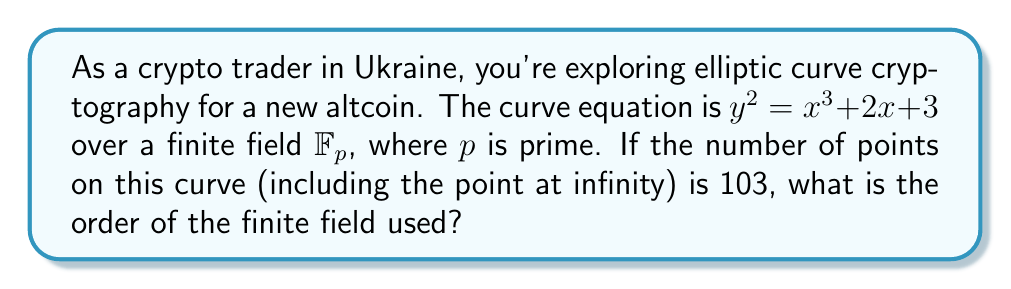Teach me how to tackle this problem. To solve this problem, we'll use Hasse's Theorem, which relates the number of points on an elliptic curve to the order of the finite field.

1) Let $N$ be the number of points on the curve (including the point at infinity). We're given that $N = 103$.

2) Hasse's Theorem states that:

   $$|N - (p + 1)| \leq 2\sqrt{p}$$

   where $p$ is the order of the finite field.

3) We can rewrite this as:

   $$p + 1 - 2\sqrt{p} \leq N \leq p + 1 + 2\sqrt{p}$$

4) Substituting $N = 103$:

   $$p + 1 - 2\sqrt{p} \leq 103 \leq p + 1 + 2\sqrt{p}$$

5) Simplifying the left inequality:

   $$p - 2\sqrt{p} - 102 \leq 0$$

6) And the right inequality:

   $$103 - p - 1 - 2\sqrt{p} \leq 0$$
   $$102 - p - 2\sqrt{p} \leq 0$$

7) We need to find a prime $p$ that satisfies both inequalities. Let's try some values:

   For $p = 101$:
   Left: $101 - 2\sqrt{101} - 102 \approx -11.1 \leq 0$ (satisfied)
   Right: $102 - 101 - 2\sqrt{101} \approx -9.1 \leq 0$ (satisfied)

8) We've found a prime $p$ that satisfies both inequalities. We can verify that there are no other primes between 97 and 109 that satisfy both inequalities.

Therefore, the order of the finite field is 101.
Answer: 101 